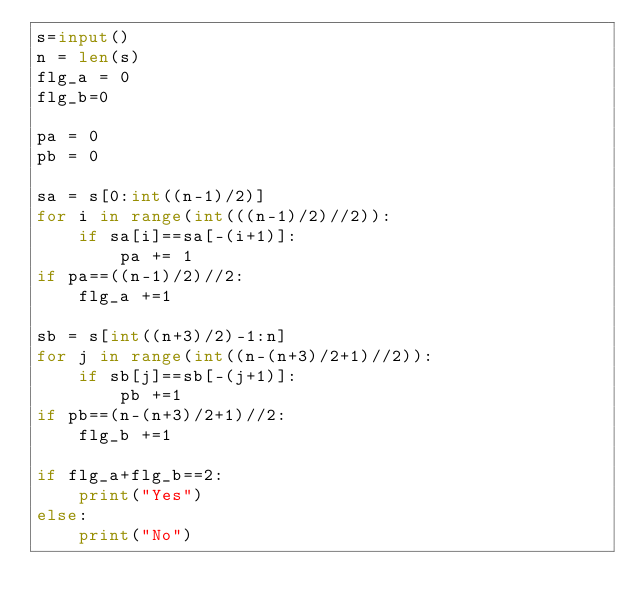<code> <loc_0><loc_0><loc_500><loc_500><_Python_>s=input()
n = len(s)
flg_a = 0
flg_b=0

pa = 0
pb = 0

sa = s[0:int((n-1)/2)]
for i in range(int(((n-1)/2)//2)):
    if sa[i]==sa[-(i+1)]:
        pa += 1
if pa==((n-1)/2)//2:
    flg_a +=1

sb = s[int((n+3)/2)-1:n]
for j in range(int((n-(n+3)/2+1)//2)):
    if sb[j]==sb[-(j+1)]:
        pb +=1
if pb==(n-(n+3)/2+1)//2:
    flg_b +=1

if flg_a+flg_b==2:
    print("Yes")
else:
    print("No")</code> 